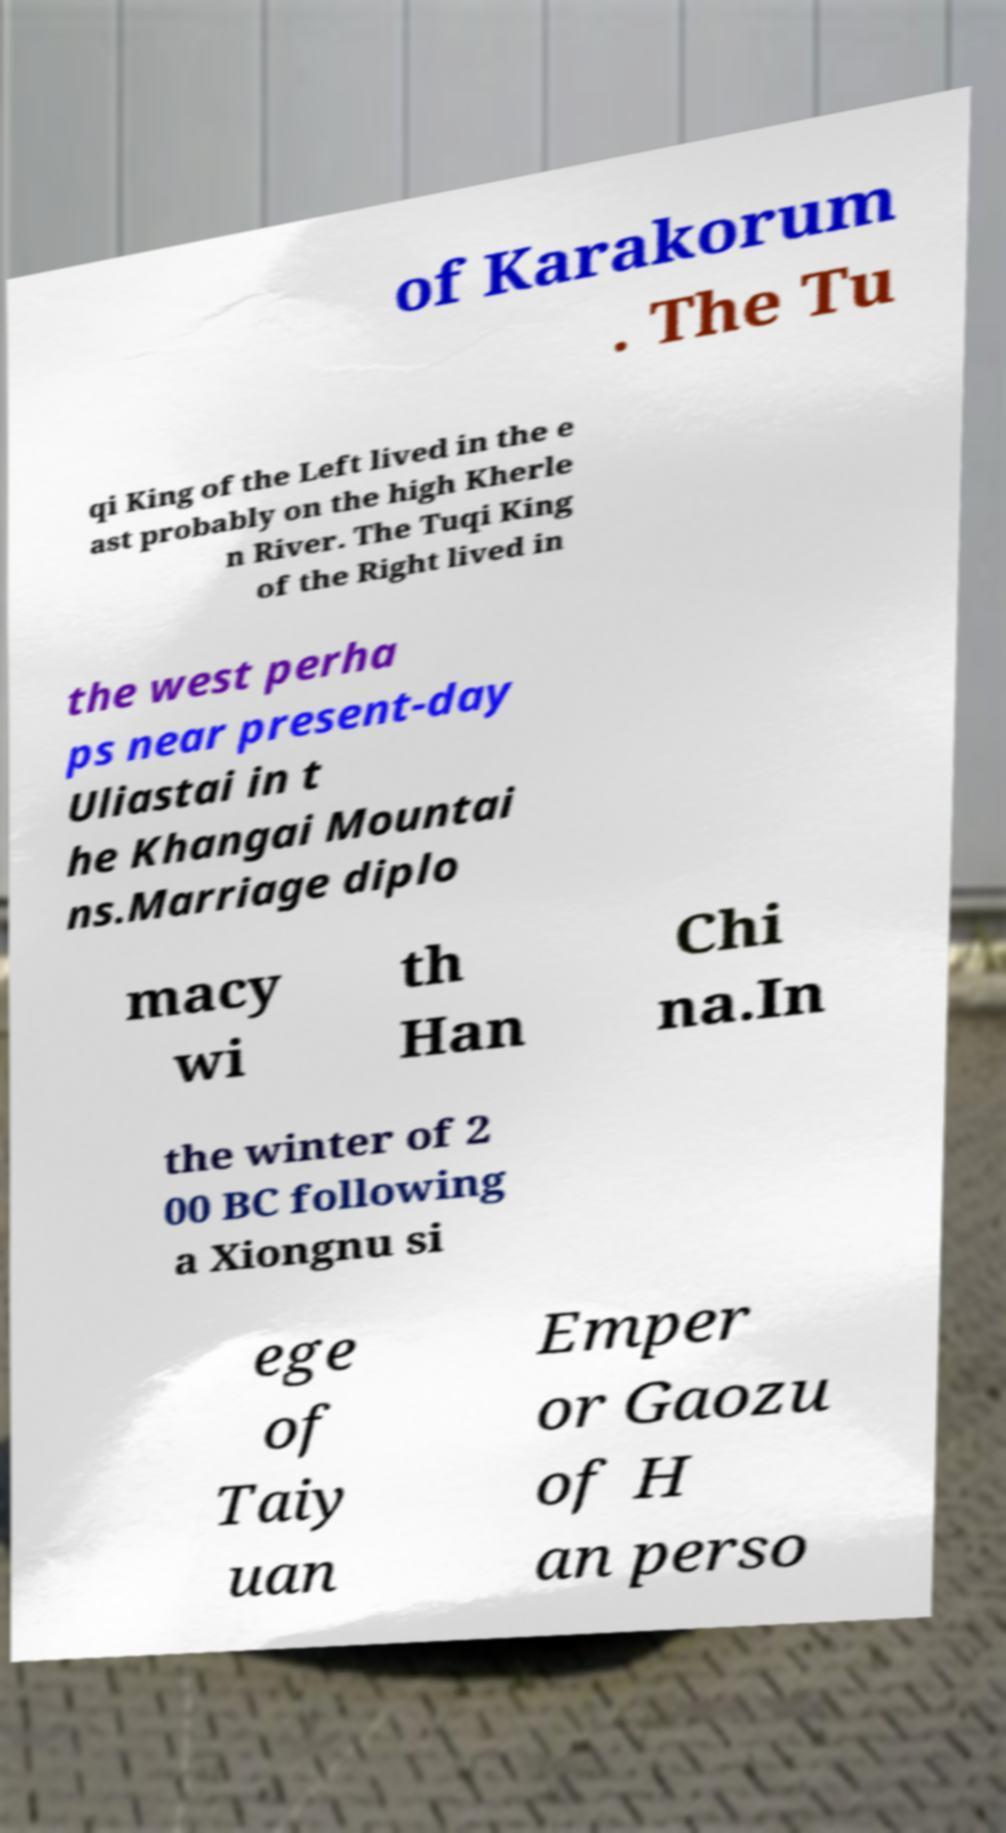Can you accurately transcribe the text from the provided image for me? of Karakorum . The Tu qi King of the Left lived in the e ast probably on the high Kherle n River. The Tuqi King of the Right lived in the west perha ps near present-day Uliastai in t he Khangai Mountai ns.Marriage diplo macy wi th Han Chi na.In the winter of 2 00 BC following a Xiongnu si ege of Taiy uan Emper or Gaozu of H an perso 